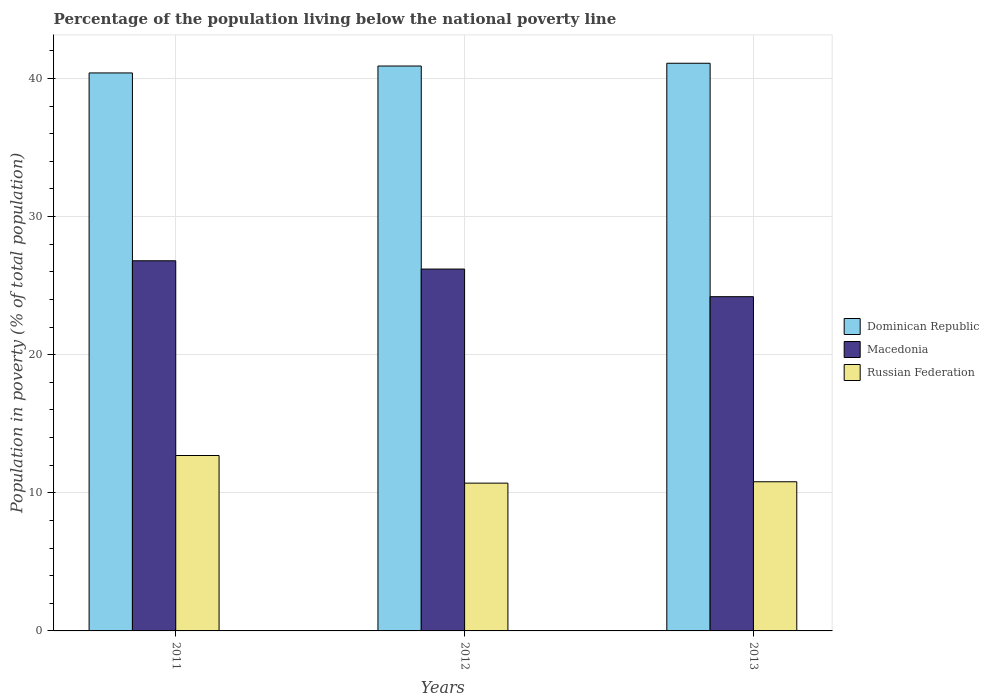Are the number of bars per tick equal to the number of legend labels?
Give a very brief answer. Yes. Are the number of bars on each tick of the X-axis equal?
Keep it short and to the point. Yes. How many bars are there on the 3rd tick from the left?
Your answer should be compact. 3. How many bars are there on the 2nd tick from the right?
Offer a terse response. 3. What is the label of the 1st group of bars from the left?
Your response must be concise. 2011. What is the percentage of the population living below the national poverty line in Dominican Republic in 2012?
Give a very brief answer. 40.9. Across all years, what is the minimum percentage of the population living below the national poverty line in Macedonia?
Your response must be concise. 24.2. What is the total percentage of the population living below the national poverty line in Macedonia in the graph?
Make the answer very short. 77.2. What is the difference between the percentage of the population living below the national poverty line in Russian Federation in 2011 and that in 2012?
Your answer should be very brief. 2. What is the difference between the percentage of the population living below the national poverty line in Russian Federation in 2011 and the percentage of the population living below the national poverty line in Macedonia in 2012?
Your response must be concise. -13.5. In the year 2012, what is the difference between the percentage of the population living below the national poverty line in Dominican Republic and percentage of the population living below the national poverty line in Macedonia?
Offer a terse response. 14.7. What is the ratio of the percentage of the population living below the national poverty line in Russian Federation in 2011 to that in 2013?
Make the answer very short. 1.18. Is the percentage of the population living below the national poverty line in Russian Federation in 2012 less than that in 2013?
Your answer should be compact. Yes. Is the difference between the percentage of the population living below the national poverty line in Dominican Republic in 2012 and 2013 greater than the difference between the percentage of the population living below the national poverty line in Macedonia in 2012 and 2013?
Your answer should be compact. No. What is the difference between the highest and the second highest percentage of the population living below the national poverty line in Russian Federation?
Offer a terse response. 1.9. What is the difference between the highest and the lowest percentage of the population living below the national poverty line in Macedonia?
Ensure brevity in your answer.  2.6. In how many years, is the percentage of the population living below the national poverty line in Dominican Republic greater than the average percentage of the population living below the national poverty line in Dominican Republic taken over all years?
Keep it short and to the point. 2. What does the 3rd bar from the left in 2013 represents?
Your response must be concise. Russian Federation. What does the 3rd bar from the right in 2012 represents?
Offer a terse response. Dominican Republic. Is it the case that in every year, the sum of the percentage of the population living below the national poverty line in Russian Federation and percentage of the population living below the national poverty line in Macedonia is greater than the percentage of the population living below the national poverty line in Dominican Republic?
Your answer should be very brief. No. How many bars are there?
Offer a terse response. 9. Are all the bars in the graph horizontal?
Your response must be concise. No. How many years are there in the graph?
Offer a very short reply. 3. What is the title of the graph?
Keep it short and to the point. Percentage of the population living below the national poverty line. Does "Uzbekistan" appear as one of the legend labels in the graph?
Your answer should be very brief. No. What is the label or title of the X-axis?
Keep it short and to the point. Years. What is the label or title of the Y-axis?
Your response must be concise. Population in poverty (% of total population). What is the Population in poverty (% of total population) in Dominican Republic in 2011?
Your answer should be very brief. 40.4. What is the Population in poverty (% of total population) of Macedonia in 2011?
Your response must be concise. 26.8. What is the Population in poverty (% of total population) in Dominican Republic in 2012?
Your answer should be very brief. 40.9. What is the Population in poverty (% of total population) in Macedonia in 2012?
Offer a terse response. 26.2. What is the Population in poverty (% of total population) of Russian Federation in 2012?
Your answer should be very brief. 10.7. What is the Population in poverty (% of total population) of Dominican Republic in 2013?
Offer a terse response. 41.1. What is the Population in poverty (% of total population) of Macedonia in 2013?
Provide a short and direct response. 24.2. Across all years, what is the maximum Population in poverty (% of total population) of Dominican Republic?
Provide a succinct answer. 41.1. Across all years, what is the maximum Population in poverty (% of total population) of Macedonia?
Offer a terse response. 26.8. Across all years, what is the maximum Population in poverty (% of total population) of Russian Federation?
Offer a terse response. 12.7. Across all years, what is the minimum Population in poverty (% of total population) in Dominican Republic?
Make the answer very short. 40.4. Across all years, what is the minimum Population in poverty (% of total population) in Macedonia?
Offer a very short reply. 24.2. What is the total Population in poverty (% of total population) in Dominican Republic in the graph?
Offer a very short reply. 122.4. What is the total Population in poverty (% of total population) of Macedonia in the graph?
Offer a very short reply. 77.2. What is the total Population in poverty (% of total population) in Russian Federation in the graph?
Give a very brief answer. 34.2. What is the difference between the Population in poverty (% of total population) in Macedonia in 2011 and that in 2012?
Offer a very short reply. 0.6. What is the difference between the Population in poverty (% of total population) in Macedonia in 2011 and that in 2013?
Provide a short and direct response. 2.6. What is the difference between the Population in poverty (% of total population) in Russian Federation in 2011 and that in 2013?
Provide a short and direct response. 1.9. What is the difference between the Population in poverty (% of total population) in Russian Federation in 2012 and that in 2013?
Provide a succinct answer. -0.1. What is the difference between the Population in poverty (% of total population) of Dominican Republic in 2011 and the Population in poverty (% of total population) of Russian Federation in 2012?
Your response must be concise. 29.7. What is the difference between the Population in poverty (% of total population) of Dominican Republic in 2011 and the Population in poverty (% of total population) of Russian Federation in 2013?
Your answer should be very brief. 29.6. What is the difference between the Population in poverty (% of total population) in Dominican Republic in 2012 and the Population in poverty (% of total population) in Russian Federation in 2013?
Ensure brevity in your answer.  30.1. What is the average Population in poverty (% of total population) of Dominican Republic per year?
Offer a very short reply. 40.8. What is the average Population in poverty (% of total population) in Macedonia per year?
Provide a succinct answer. 25.73. What is the average Population in poverty (% of total population) of Russian Federation per year?
Ensure brevity in your answer.  11.4. In the year 2011, what is the difference between the Population in poverty (% of total population) in Dominican Republic and Population in poverty (% of total population) in Russian Federation?
Provide a succinct answer. 27.7. In the year 2011, what is the difference between the Population in poverty (% of total population) of Macedonia and Population in poverty (% of total population) of Russian Federation?
Keep it short and to the point. 14.1. In the year 2012, what is the difference between the Population in poverty (% of total population) of Dominican Republic and Population in poverty (% of total population) of Russian Federation?
Offer a terse response. 30.2. In the year 2012, what is the difference between the Population in poverty (% of total population) of Macedonia and Population in poverty (% of total population) of Russian Federation?
Make the answer very short. 15.5. In the year 2013, what is the difference between the Population in poverty (% of total population) in Dominican Republic and Population in poverty (% of total population) in Russian Federation?
Your response must be concise. 30.3. What is the ratio of the Population in poverty (% of total population) of Dominican Republic in 2011 to that in 2012?
Give a very brief answer. 0.99. What is the ratio of the Population in poverty (% of total population) of Macedonia in 2011 to that in 2012?
Provide a succinct answer. 1.02. What is the ratio of the Population in poverty (% of total population) of Russian Federation in 2011 to that in 2012?
Provide a succinct answer. 1.19. What is the ratio of the Population in poverty (% of total population) in Dominican Republic in 2011 to that in 2013?
Provide a short and direct response. 0.98. What is the ratio of the Population in poverty (% of total population) of Macedonia in 2011 to that in 2013?
Provide a succinct answer. 1.11. What is the ratio of the Population in poverty (% of total population) in Russian Federation in 2011 to that in 2013?
Provide a short and direct response. 1.18. What is the ratio of the Population in poverty (% of total population) of Dominican Republic in 2012 to that in 2013?
Ensure brevity in your answer.  1. What is the ratio of the Population in poverty (% of total population) of Macedonia in 2012 to that in 2013?
Provide a short and direct response. 1.08. What is the difference between the highest and the second highest Population in poverty (% of total population) of Russian Federation?
Your answer should be very brief. 1.9. What is the difference between the highest and the lowest Population in poverty (% of total population) in Macedonia?
Make the answer very short. 2.6. 